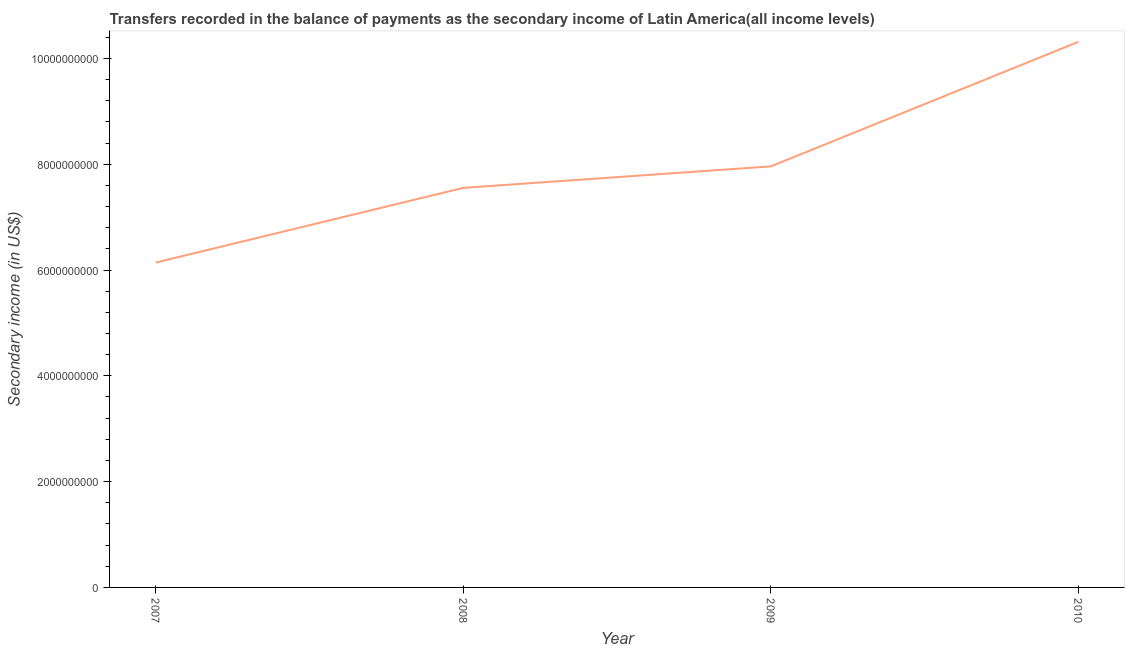What is the amount of secondary income in 2008?
Give a very brief answer. 7.55e+09. Across all years, what is the maximum amount of secondary income?
Ensure brevity in your answer.  1.03e+1. Across all years, what is the minimum amount of secondary income?
Offer a terse response. 6.14e+09. In which year was the amount of secondary income maximum?
Your answer should be compact. 2010. In which year was the amount of secondary income minimum?
Keep it short and to the point. 2007. What is the sum of the amount of secondary income?
Provide a succinct answer. 3.20e+1. What is the difference between the amount of secondary income in 2008 and 2009?
Offer a very short reply. -4.06e+08. What is the average amount of secondary income per year?
Offer a very short reply. 7.99e+09. What is the median amount of secondary income?
Make the answer very short. 7.76e+09. Do a majority of the years between 2009 and 2008 (inclusive) have amount of secondary income greater than 9200000000 US$?
Provide a succinct answer. No. What is the ratio of the amount of secondary income in 2007 to that in 2009?
Provide a succinct answer. 0.77. What is the difference between the highest and the second highest amount of secondary income?
Your answer should be very brief. 2.35e+09. What is the difference between the highest and the lowest amount of secondary income?
Offer a very short reply. 4.17e+09. Does the amount of secondary income monotonically increase over the years?
Offer a very short reply. Yes. How many years are there in the graph?
Offer a terse response. 4. What is the difference between two consecutive major ticks on the Y-axis?
Make the answer very short. 2.00e+09. Are the values on the major ticks of Y-axis written in scientific E-notation?
Give a very brief answer. No. Does the graph contain grids?
Ensure brevity in your answer.  No. What is the title of the graph?
Your answer should be very brief. Transfers recorded in the balance of payments as the secondary income of Latin America(all income levels). What is the label or title of the X-axis?
Ensure brevity in your answer.  Year. What is the label or title of the Y-axis?
Offer a terse response. Secondary income (in US$). What is the Secondary income (in US$) of 2007?
Your answer should be very brief. 6.14e+09. What is the Secondary income (in US$) in 2008?
Ensure brevity in your answer.  7.55e+09. What is the Secondary income (in US$) of 2009?
Ensure brevity in your answer.  7.96e+09. What is the Secondary income (in US$) of 2010?
Your response must be concise. 1.03e+1. What is the difference between the Secondary income (in US$) in 2007 and 2008?
Keep it short and to the point. -1.41e+09. What is the difference between the Secondary income (in US$) in 2007 and 2009?
Offer a very short reply. -1.82e+09. What is the difference between the Secondary income (in US$) in 2007 and 2010?
Provide a succinct answer. -4.17e+09. What is the difference between the Secondary income (in US$) in 2008 and 2009?
Give a very brief answer. -4.06e+08. What is the difference between the Secondary income (in US$) in 2008 and 2010?
Your answer should be compact. -2.76e+09. What is the difference between the Secondary income (in US$) in 2009 and 2010?
Your response must be concise. -2.35e+09. What is the ratio of the Secondary income (in US$) in 2007 to that in 2008?
Offer a very short reply. 0.81. What is the ratio of the Secondary income (in US$) in 2007 to that in 2009?
Make the answer very short. 0.77. What is the ratio of the Secondary income (in US$) in 2007 to that in 2010?
Your answer should be compact. 0.59. What is the ratio of the Secondary income (in US$) in 2008 to that in 2009?
Your response must be concise. 0.95. What is the ratio of the Secondary income (in US$) in 2008 to that in 2010?
Provide a succinct answer. 0.73. What is the ratio of the Secondary income (in US$) in 2009 to that in 2010?
Offer a very short reply. 0.77. 